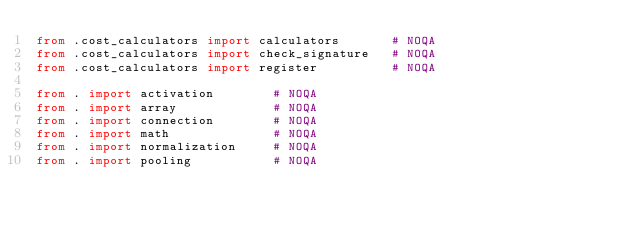<code> <loc_0><loc_0><loc_500><loc_500><_Python_>from .cost_calculators import calculators       # NOQA
from .cost_calculators import check_signature   # NOQA
from .cost_calculators import register          # NOQA

from . import activation        # NOQA
from . import array             # NOQA
from . import connection        # NOQA
from . import math              # NOQA
from . import normalization     # NOQA
from . import pooling           # NOQA
</code> 